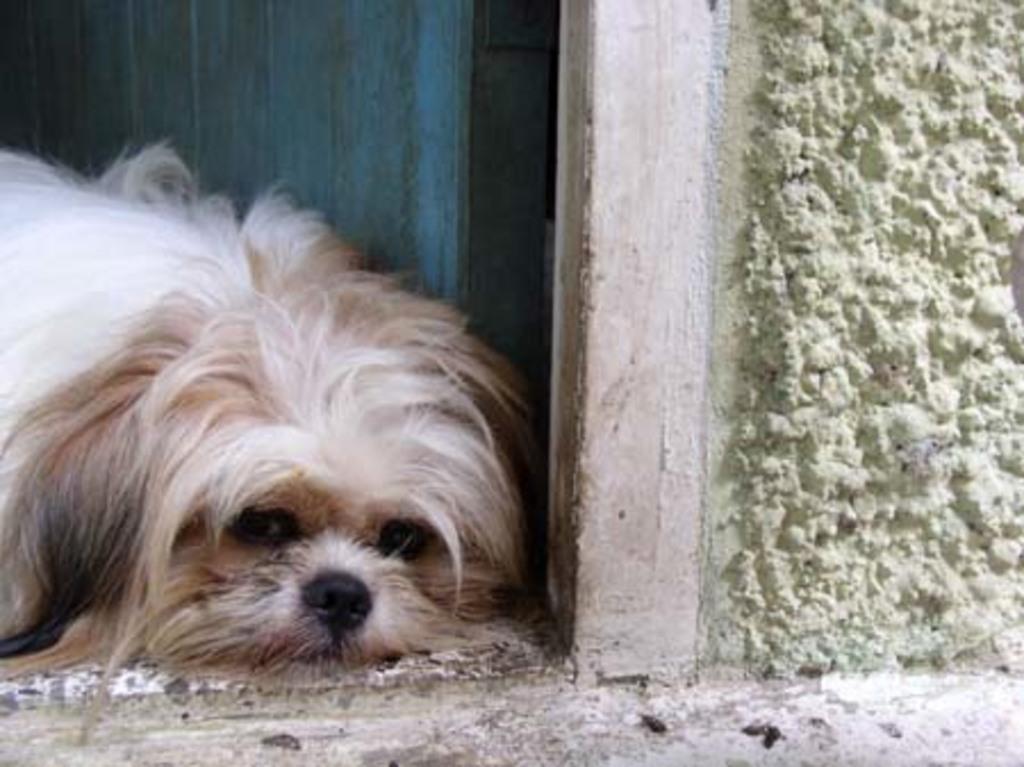Could you give a brief overview of what you see in this image? In this picture I can see a dog and a wooden door in the back. I can see a wall on the right side of the picture. 